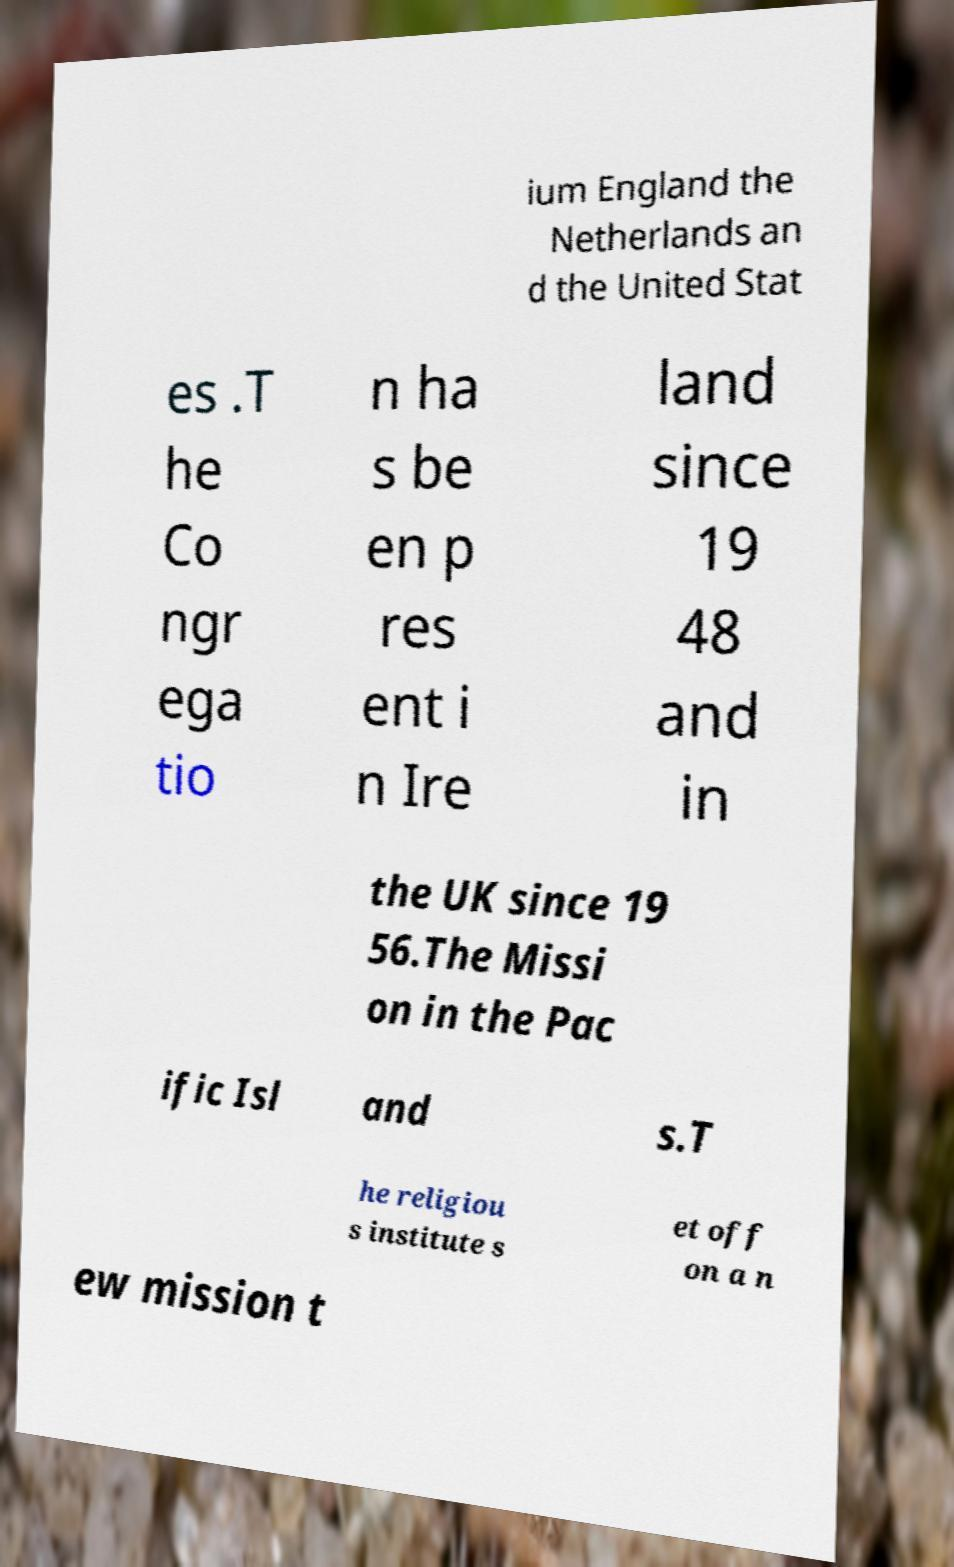For documentation purposes, I need the text within this image transcribed. Could you provide that? ium England the Netherlands an d the United Stat es .T he Co ngr ega tio n ha s be en p res ent i n Ire land since 19 48 and in the UK since 19 56.The Missi on in the Pac ific Isl and s.T he religiou s institute s et off on a n ew mission t 